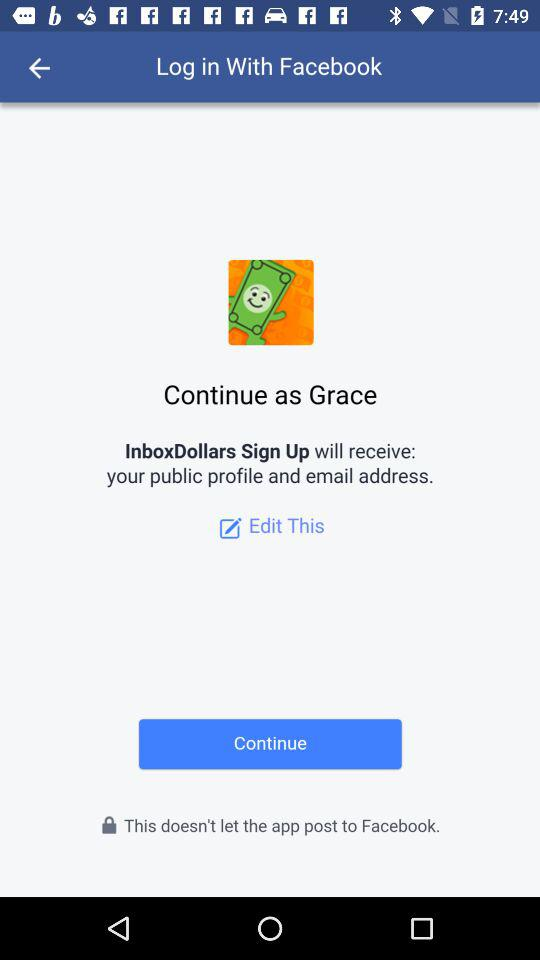Through what application can we log in? You can log in through "Facebook". 